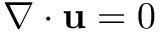<formula> <loc_0><loc_0><loc_500><loc_500>\nabla \cdot u = 0</formula> 